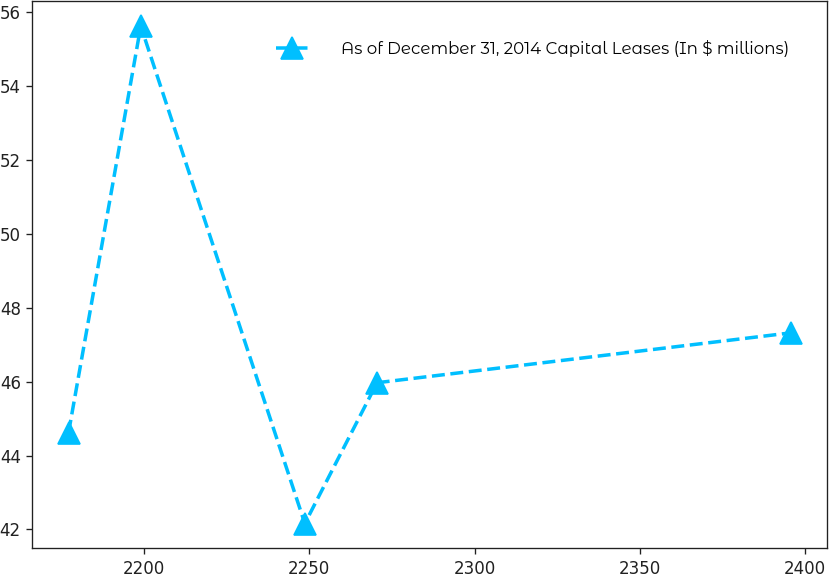Convert chart to OTSL. <chart><loc_0><loc_0><loc_500><loc_500><line_chart><ecel><fcel>As of December 31, 2014 Capital Leases (In $ millions)<nl><fcel>2177.09<fcel>44.62<nl><fcel>2198.96<fcel>55.62<nl><fcel>2248.63<fcel>42.16<nl><fcel>2270.5<fcel>45.97<nl><fcel>2395.78<fcel>47.32<nl></chart> 